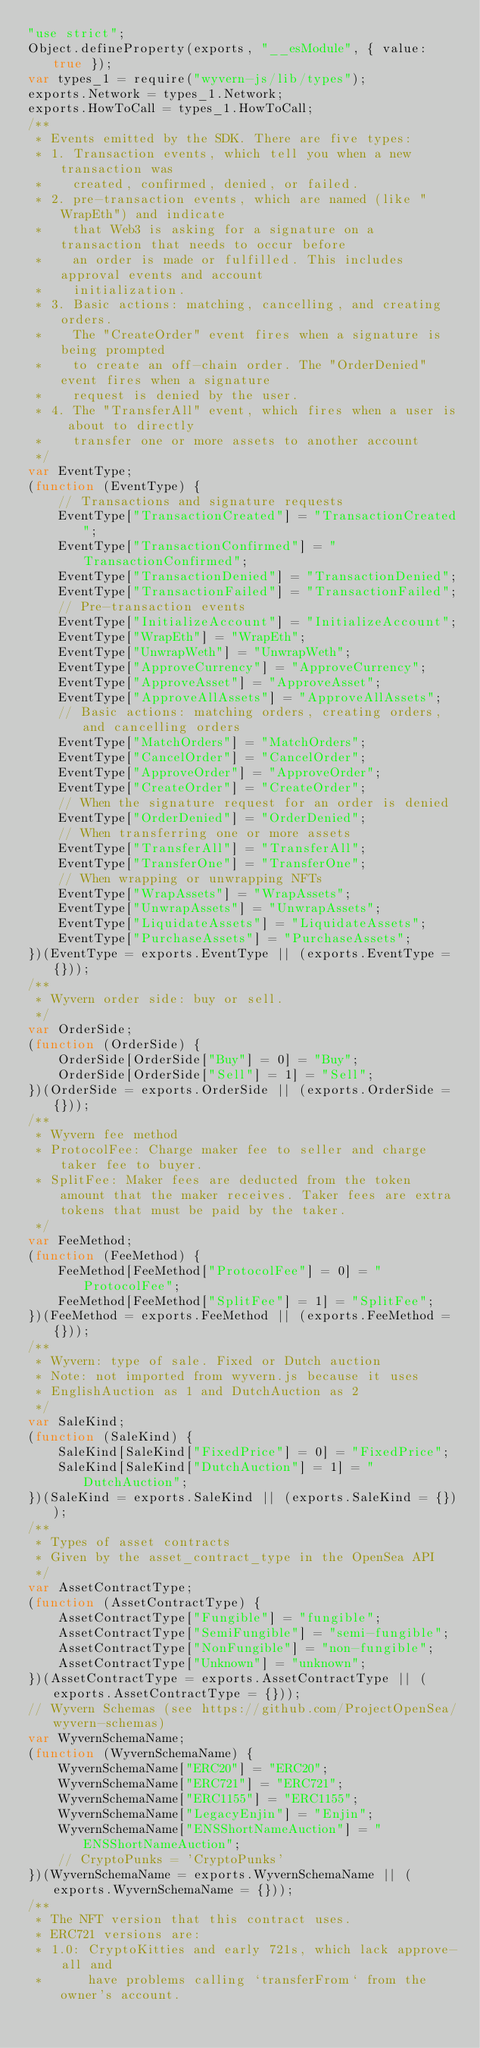<code> <loc_0><loc_0><loc_500><loc_500><_JavaScript_>"use strict";
Object.defineProperty(exports, "__esModule", { value: true });
var types_1 = require("wyvern-js/lib/types");
exports.Network = types_1.Network;
exports.HowToCall = types_1.HowToCall;
/**
 * Events emitted by the SDK. There are five types:
 * 1. Transaction events, which tell you when a new transaction was
 *    created, confirmed, denied, or failed.
 * 2. pre-transaction events, which are named (like "WrapEth") and indicate
 *    that Web3 is asking for a signature on a transaction that needs to occur before
 *    an order is made or fulfilled. This includes approval events and account
 *    initialization.
 * 3. Basic actions: matching, cancelling, and creating orders.
 *    The "CreateOrder" event fires when a signature is being prompted
 *    to create an off-chain order. The "OrderDenied" event fires when a signature
 *    request is denied by the user.
 * 4. The "TransferAll" event, which fires when a user is about to directly
 *    transfer one or more assets to another account
 */
var EventType;
(function (EventType) {
    // Transactions and signature requests
    EventType["TransactionCreated"] = "TransactionCreated";
    EventType["TransactionConfirmed"] = "TransactionConfirmed";
    EventType["TransactionDenied"] = "TransactionDenied";
    EventType["TransactionFailed"] = "TransactionFailed";
    // Pre-transaction events
    EventType["InitializeAccount"] = "InitializeAccount";
    EventType["WrapEth"] = "WrapEth";
    EventType["UnwrapWeth"] = "UnwrapWeth";
    EventType["ApproveCurrency"] = "ApproveCurrency";
    EventType["ApproveAsset"] = "ApproveAsset";
    EventType["ApproveAllAssets"] = "ApproveAllAssets";
    // Basic actions: matching orders, creating orders, and cancelling orders
    EventType["MatchOrders"] = "MatchOrders";
    EventType["CancelOrder"] = "CancelOrder";
    EventType["ApproveOrder"] = "ApproveOrder";
    EventType["CreateOrder"] = "CreateOrder";
    // When the signature request for an order is denied
    EventType["OrderDenied"] = "OrderDenied";
    // When transferring one or more assets
    EventType["TransferAll"] = "TransferAll";
    EventType["TransferOne"] = "TransferOne";
    // When wrapping or unwrapping NFTs
    EventType["WrapAssets"] = "WrapAssets";
    EventType["UnwrapAssets"] = "UnwrapAssets";
    EventType["LiquidateAssets"] = "LiquidateAssets";
    EventType["PurchaseAssets"] = "PurchaseAssets";
})(EventType = exports.EventType || (exports.EventType = {}));
/**
 * Wyvern order side: buy or sell.
 */
var OrderSide;
(function (OrderSide) {
    OrderSide[OrderSide["Buy"] = 0] = "Buy";
    OrderSide[OrderSide["Sell"] = 1] = "Sell";
})(OrderSide = exports.OrderSide || (exports.OrderSide = {}));
/**
 * Wyvern fee method
 * ProtocolFee: Charge maker fee to seller and charge taker fee to buyer.
 * SplitFee: Maker fees are deducted from the token amount that the maker receives. Taker fees are extra tokens that must be paid by the taker.
 */
var FeeMethod;
(function (FeeMethod) {
    FeeMethod[FeeMethod["ProtocolFee"] = 0] = "ProtocolFee";
    FeeMethod[FeeMethod["SplitFee"] = 1] = "SplitFee";
})(FeeMethod = exports.FeeMethod || (exports.FeeMethod = {}));
/**
 * Wyvern: type of sale. Fixed or Dutch auction
 * Note: not imported from wyvern.js because it uses
 * EnglishAuction as 1 and DutchAuction as 2
 */
var SaleKind;
(function (SaleKind) {
    SaleKind[SaleKind["FixedPrice"] = 0] = "FixedPrice";
    SaleKind[SaleKind["DutchAuction"] = 1] = "DutchAuction";
})(SaleKind = exports.SaleKind || (exports.SaleKind = {}));
/**
 * Types of asset contracts
 * Given by the asset_contract_type in the OpenSea API
 */
var AssetContractType;
(function (AssetContractType) {
    AssetContractType["Fungible"] = "fungible";
    AssetContractType["SemiFungible"] = "semi-fungible";
    AssetContractType["NonFungible"] = "non-fungible";
    AssetContractType["Unknown"] = "unknown";
})(AssetContractType = exports.AssetContractType || (exports.AssetContractType = {}));
// Wyvern Schemas (see https://github.com/ProjectOpenSea/wyvern-schemas)
var WyvernSchemaName;
(function (WyvernSchemaName) {
    WyvernSchemaName["ERC20"] = "ERC20";
    WyvernSchemaName["ERC721"] = "ERC721";
    WyvernSchemaName["ERC1155"] = "ERC1155";
    WyvernSchemaName["LegacyEnjin"] = "Enjin";
    WyvernSchemaName["ENSShortNameAuction"] = "ENSShortNameAuction";
    // CryptoPunks = 'CryptoPunks'
})(WyvernSchemaName = exports.WyvernSchemaName || (exports.WyvernSchemaName = {}));
/**
 * The NFT version that this contract uses.
 * ERC721 versions are:
 * 1.0: CryptoKitties and early 721s, which lack approve-all and
 *      have problems calling `transferFrom` from the owner's account.</code> 